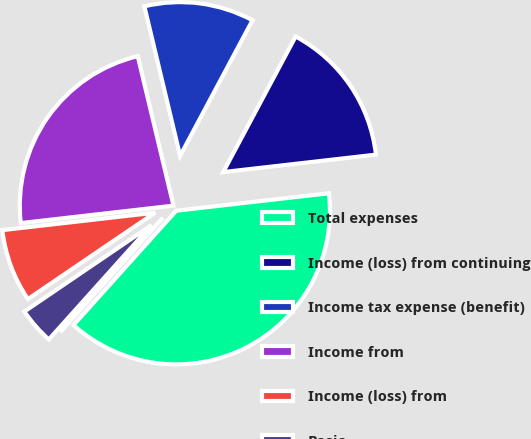Convert chart. <chart><loc_0><loc_0><loc_500><loc_500><pie_chart><fcel>Total expenses<fcel>Income (loss) from continuing<fcel>Income tax expense (benefit)<fcel>Income from<fcel>Income (loss) from<fcel>Basic<fcel>Diluted<nl><fcel>38.45%<fcel>15.38%<fcel>11.54%<fcel>23.07%<fcel>7.69%<fcel>3.85%<fcel>0.0%<nl></chart> 